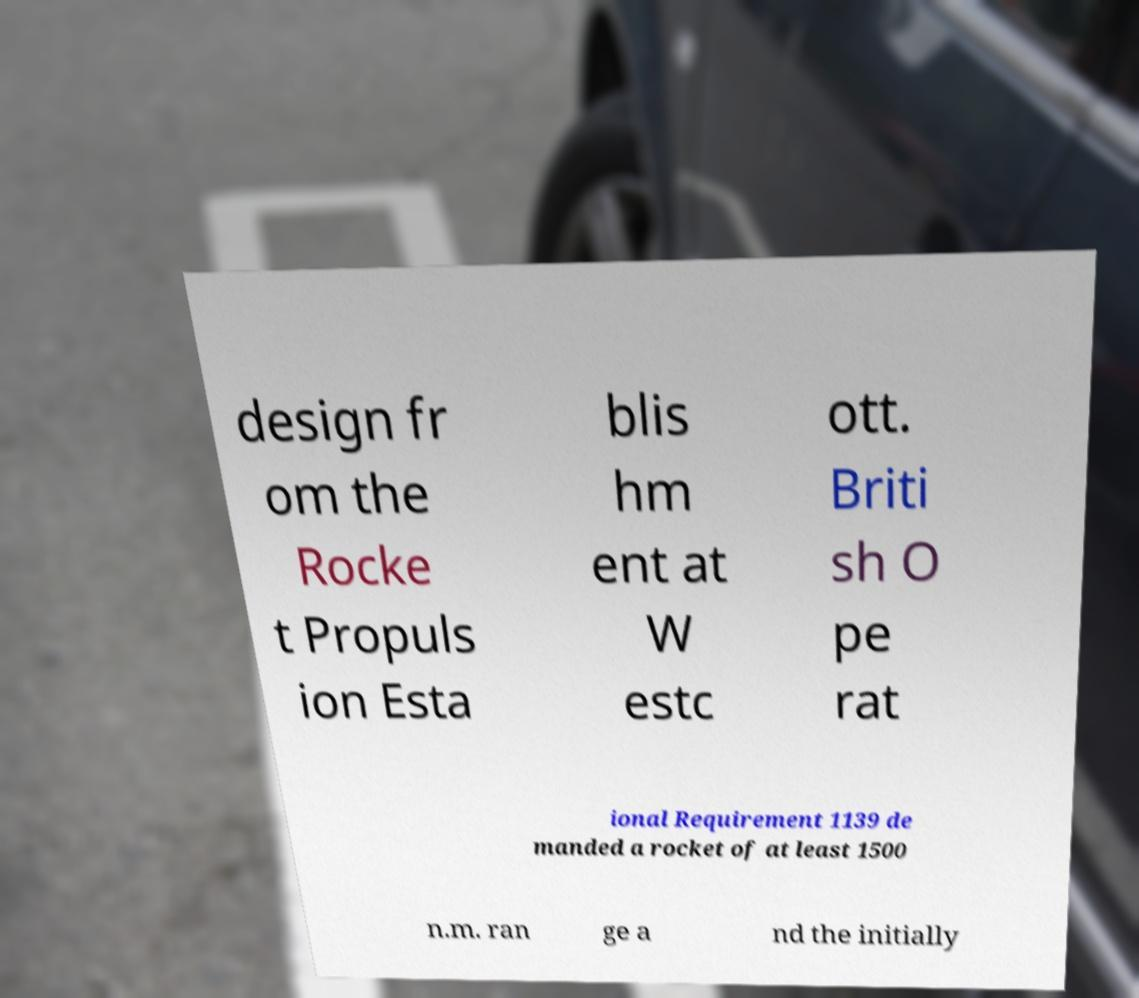Please identify and transcribe the text found in this image. design fr om the Rocke t Propuls ion Esta blis hm ent at W estc ott. Briti sh O pe rat ional Requirement 1139 de manded a rocket of at least 1500 n.m. ran ge a nd the initially 